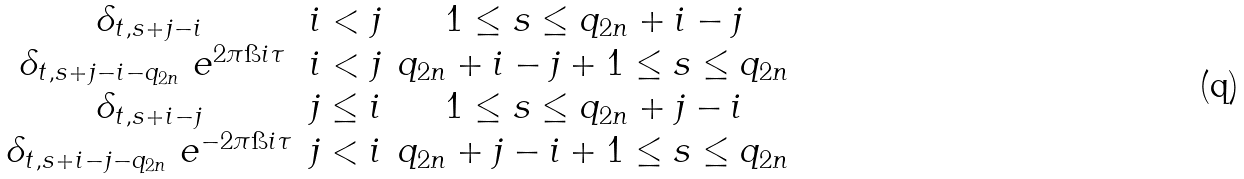Convert formula to latex. <formula><loc_0><loc_0><loc_500><loc_500>\begin{matrix} \delta _ { t , s + j - i } & i < j & 1 \leq s \leq q _ { 2 n } + i - j \\ \, \delta _ { t , s + j - i - q _ { 2 n } } \ e ^ { 2 \pi \i i \tau } & i < j & q _ { 2 n } + i - j + 1 \leq s \leq q _ { 2 n } \\ \delta _ { t , s + i - j } & j \leq i & 1 \leq s \leq q _ { 2 n } + j - i \\ \delta _ { t , s + i - j - q _ { 2 n } } \ e ^ { - 2 \pi \i i \tau } & j < i & q _ { 2 n } + j - i + 1 \leq s \leq q _ { 2 n } \end{matrix}</formula> 